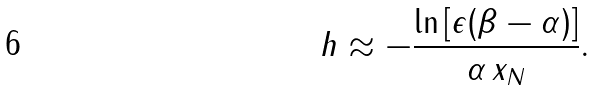<formula> <loc_0><loc_0><loc_500><loc_500>h \approx - \frac { \ln \left [ \epsilon ( \beta - \alpha ) \right ] } { \alpha \, x _ { N } } .</formula> 